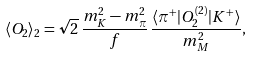Convert formula to latex. <formula><loc_0><loc_0><loc_500><loc_500>\langle O _ { 2 } \rangle _ { 2 } = \sqrt { 2 } \, \frac { m _ { K } ^ { 2 } - m _ { \pi } ^ { 2 } } { f } \, \frac { \langle \pi ^ { + } | O _ { 2 } ^ { ( 2 ) } | K ^ { + } \rangle } { m _ { M } ^ { 2 } } ,</formula> 